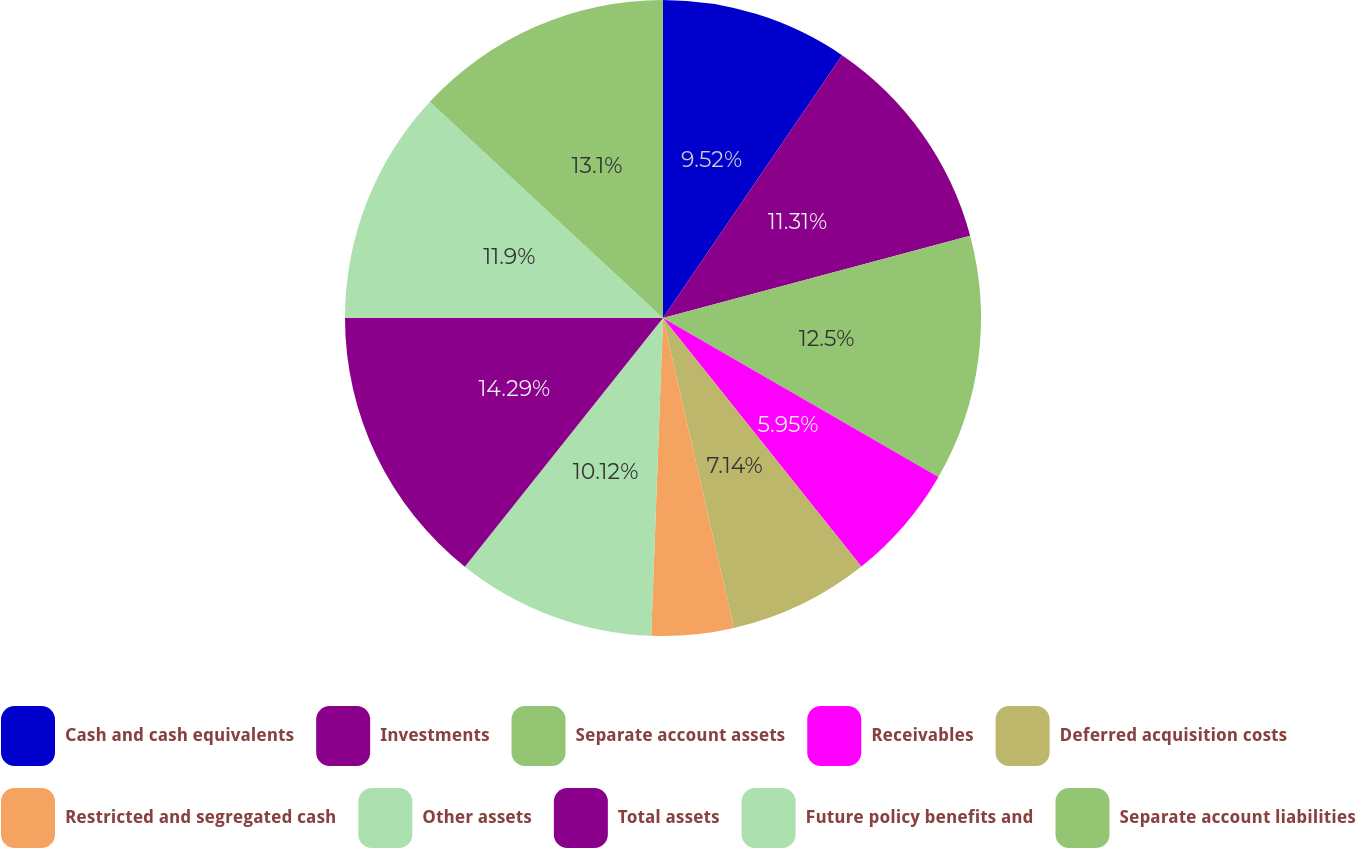Convert chart. <chart><loc_0><loc_0><loc_500><loc_500><pie_chart><fcel>Cash and cash equivalents<fcel>Investments<fcel>Separate account assets<fcel>Receivables<fcel>Deferred acquisition costs<fcel>Restricted and segregated cash<fcel>Other assets<fcel>Total assets<fcel>Future policy benefits and<fcel>Separate account liabilities<nl><fcel>9.52%<fcel>11.31%<fcel>12.5%<fcel>5.95%<fcel>7.14%<fcel>4.17%<fcel>10.12%<fcel>14.29%<fcel>11.9%<fcel>13.1%<nl></chart> 